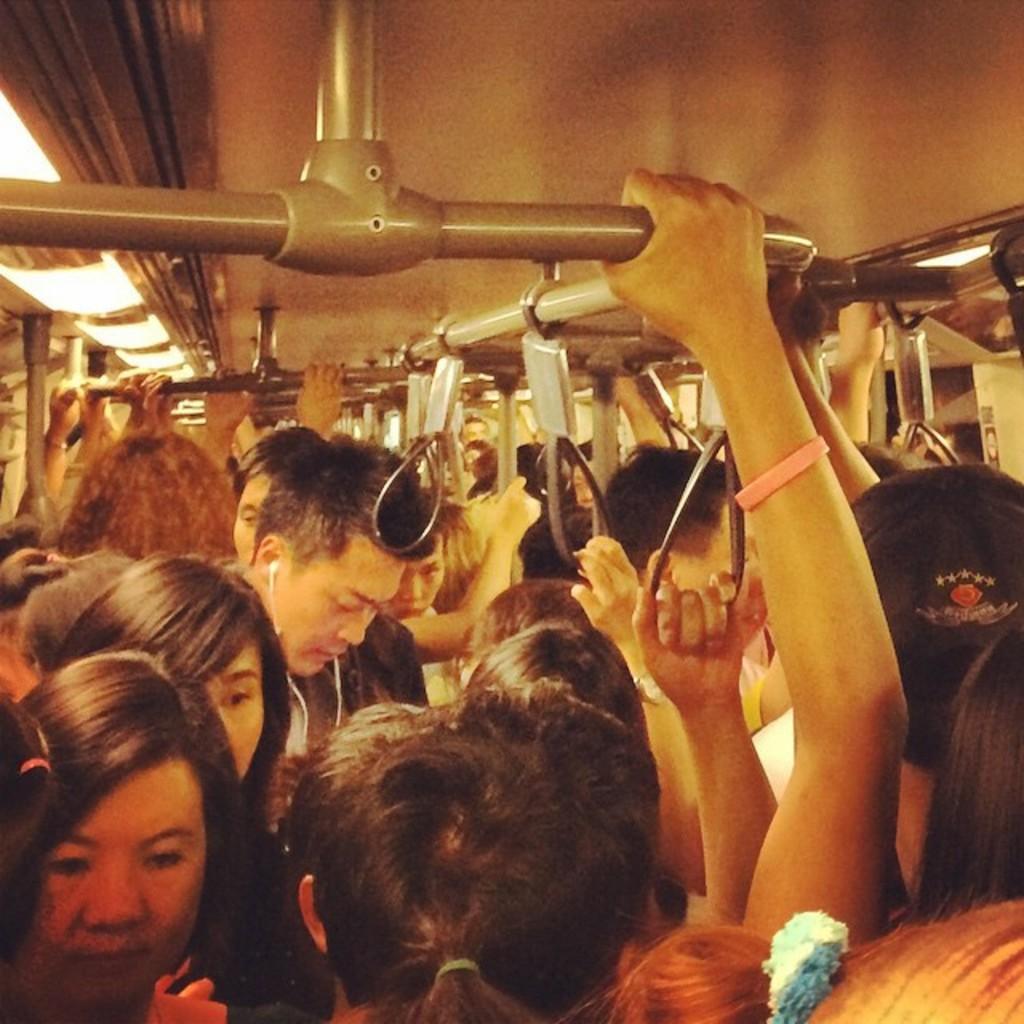How would you summarize this image in a sentence or two? In this image there are so many people standing in the bus holding hangers and poles from the top. 